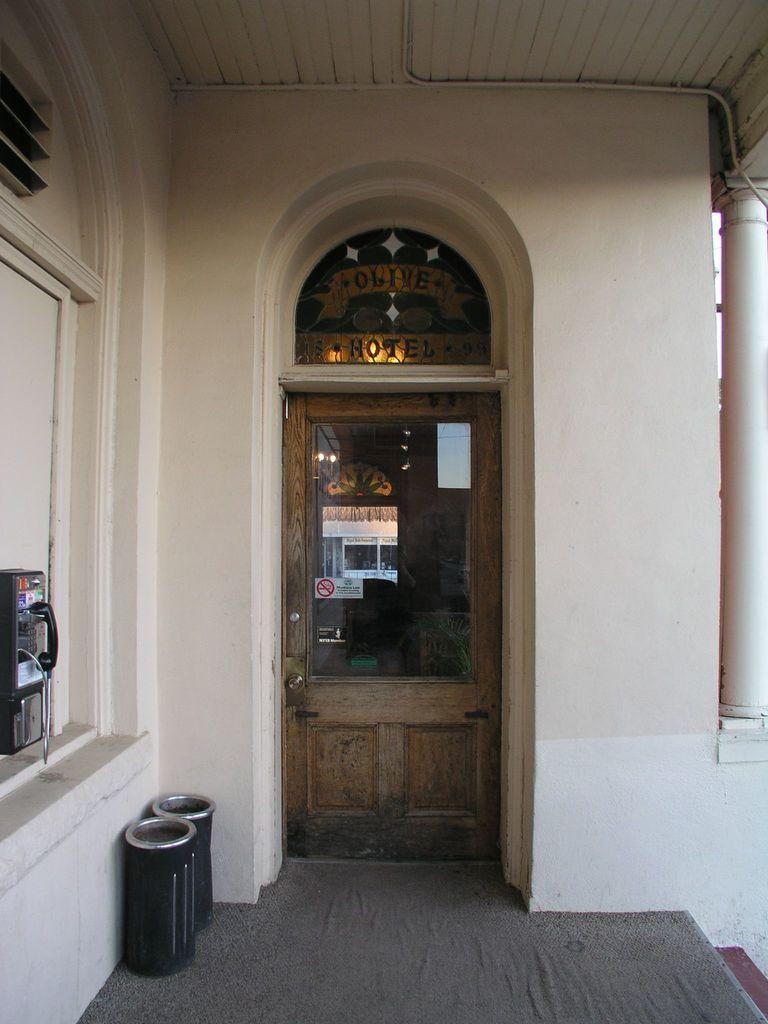How would you summarize this image in a sentence or two? In the center of the image there is a door. There is wall. To the left side of the image there are bins. There is a phone box on the wall. At the top of the image there is ceiling. 